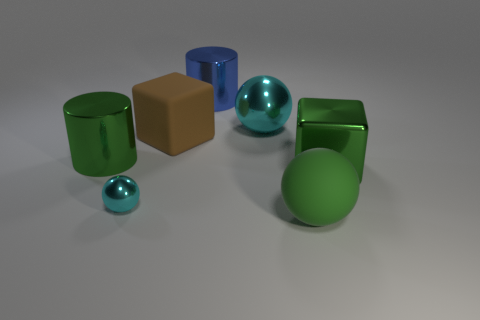Which of the objects in the image could be described as having a glossy finish? The cylindrical green object on the left, the blue cylinder in the middle, and both spherical cyan objects exhibit a glossy finish that reflects the light, creating visible highlights and giving them a shiny appearance. 